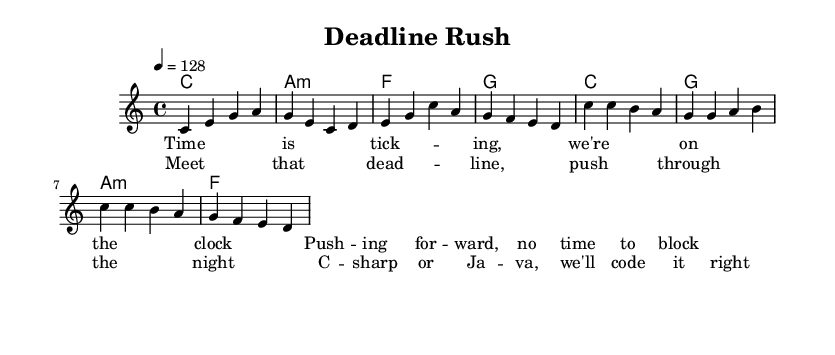What is the key signature of this music? The key signature is C major, indicated by the absence of sharps or flats in the key signature section.
Answer: C major What is the time signature of the music? The time signature is represented as 4/4, which indicates four beats per measure, with a quarter note receiving one beat.
Answer: 4/4 What is the tempo marking of the piece? The tempo marking is given as 4 equals 128, which indicates the beats per minute for the piece, setting an upbeat pace for the song.
Answer: 128 How many measures are there in the verse? By counting the measures notated in the melody section under the verse, there are four measures total.
Answer: 4 What is the first chord of the chorus? The first chord in the chorus is C major, as indicated by the chord symbol directly before the melody line for the chorus section.
Answer: C What do the lyrics in the chorus emphasize regarding coding? The lyrics highlight the importance of overcoming the challenge of coding in either C# or Java to meet deadlines, signifying adaptability in a fast-paced work environment.
Answer: C sharp or Java Which musical section has a repeat of the melody? The chorus section features a repeated melodic line with variations in the lyrics, which is common in pop music for emphasizing the main message.
Answer: Chorus 